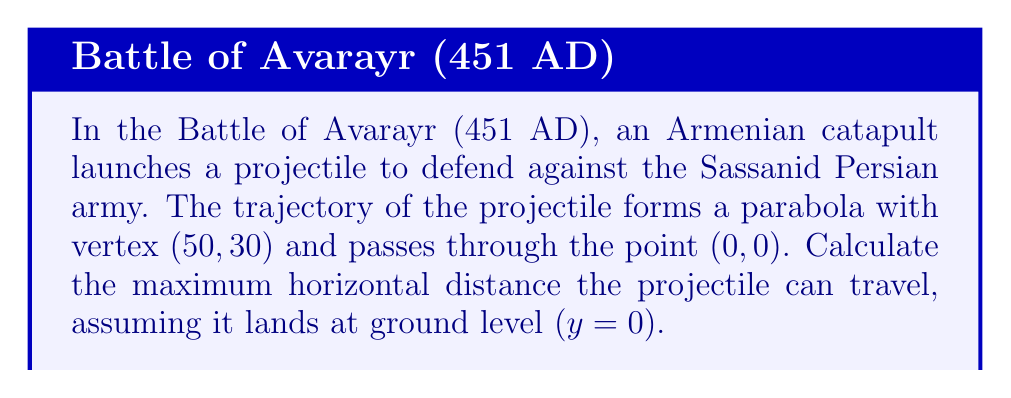Teach me how to tackle this problem. Let's approach this step-by-step using conic sections, specifically a parabola:

1) The general form of a parabola with vertical axis of symmetry is:
   $$(x-h)^2 = 4p(y-k)$$
   where $(h,k)$ is the vertex and $p$ is the focal parameter.

2) We're given the vertex (50, 30), so $h=50$ and $k=30$. Our equation becomes:
   $$(x-50)^2 = 4p(y-30)$$

3) We know the parabola passes through (0, 0). Let's substitute this point:
   $$(0-50)^2 = 4p(0-30)$$
   $$2500 = -120p$$
   $$p = -\frac{2500}{120} = -\frac{25}{1.2} \approx -20.83$$

4) Now our parabola equation is:
   $$(x-50)^2 = -83.33(y-30)$$

5) To find the maximum horizontal distance, we need to find the other x-intercept. At y = 0:
   $$(x-50)^2 = -83.33(-30)$$
   $$(x-50)^2 = 2500$$
   $$x-50 = \pm 50$$
   $$x = 100 \text{ or } x = 0$$

6) The maximum horizontal distance is the difference between these x-values:
   $$100 - 0 = 100$$

Therefore, the maximum horizontal distance the projectile can travel is 100 units.
Answer: 100 units 